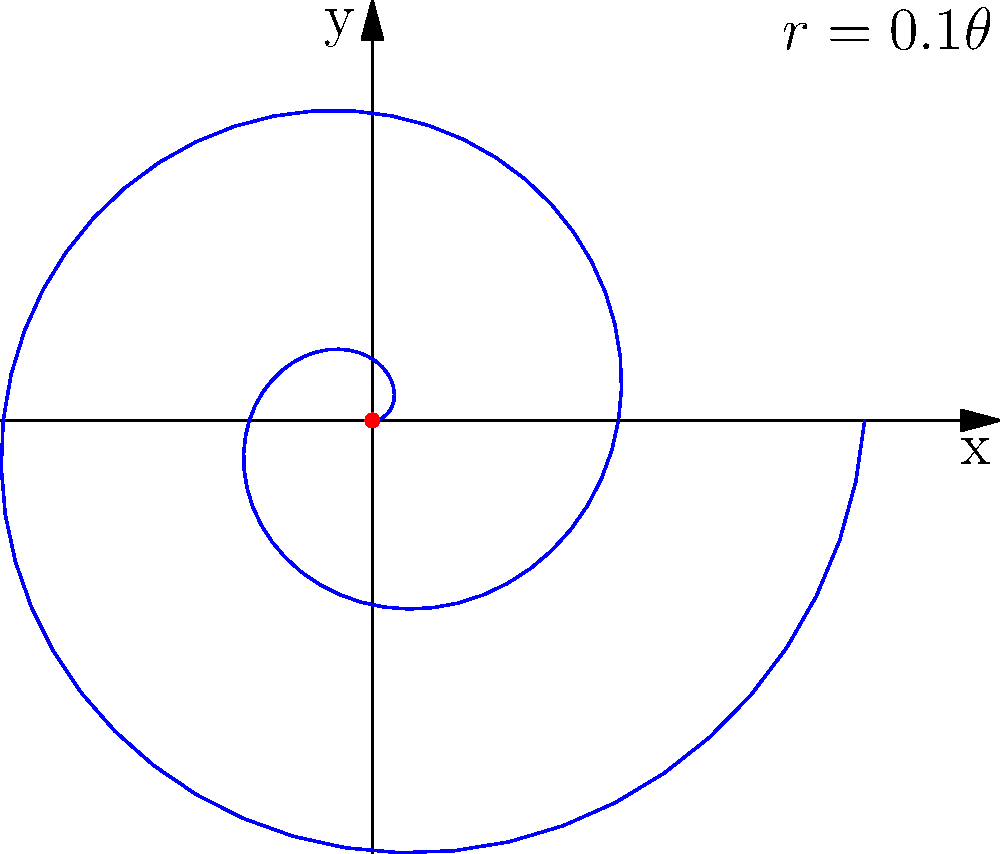Consider a spiral curve defined by the polar equation $r = 0.1\theta$, where $r$ is the radius and $\theta$ is the angle in radians. Calculate the length of the spiral from $\theta = 0$ to $\theta = 4\pi$. Round your answer to two decimal places. To calculate the length of a spiral curve defined in polar coordinates, we can use the following steps:

1. The formula for the length of a curve in polar coordinates is:
   $$L = \int_a^b \sqrt{r^2 + \left(\frac{dr}{d\theta}\right)^2} d\theta$$

2. For our spiral, $r = 0.1\theta$, so $\frac{dr}{d\theta} = 0.1$

3. Substituting into the formula:
   $$L = \int_0^{4\pi} \sqrt{(0.1\theta)^2 + (0.1)^2} d\theta$$

4. Simplify inside the square root:
   $$L = \int_0^{4\pi} \sqrt{0.01\theta^2 + 0.01} d\theta$$
   $$L = 0.1 \int_0^{4\pi} \sqrt{\theta^2 + 1} d\theta$$

5. This integral doesn't have a simple antiderivative, so we need to use numerical integration methods or a calculator with integration capabilities.

6. Using a calculator or computer algebra system, we get:
   $$L \approx 5.0766$$

7. Rounding to two decimal places:
   $$L \approx 5.08$$

Therefore, the length of the spiral from $\theta = 0$ to $\theta = 4\pi$ is approximately 5.08 units.
Answer: 5.08 units 